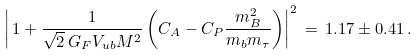Convert formula to latex. <formula><loc_0><loc_0><loc_500><loc_500>\left | \, 1 + \frac { 1 } { \sqrt { 2 } \, G _ { F } V _ { u b } M ^ { 2 } } \left ( C _ { A } - C _ { P } \frac { m _ { B } ^ { 2 } } { m _ { b } m _ { \tau } } \right ) \right | ^ { 2 } \, = \, 1 . 1 7 \pm 0 . 4 1 \, .</formula> 